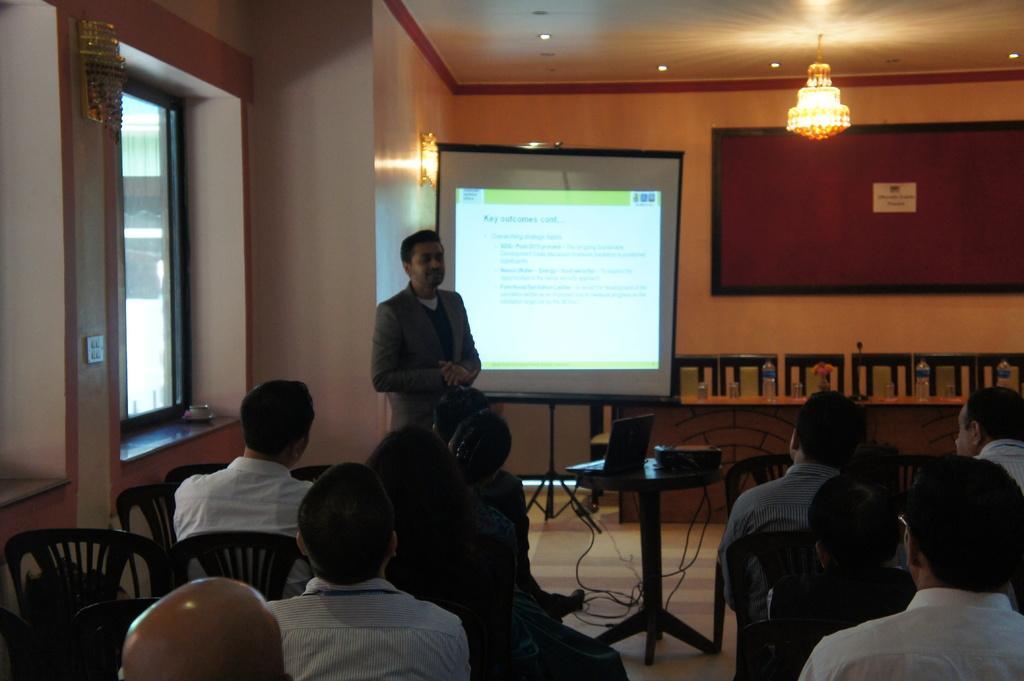Can you describe this image briefly? In this picture we can see a group of people sitting on chairs and a man is standing on the path. Behind the people there is a table and on the table there is a laptop and projector. Behind the man there is a projector screen and a wall. There are ceiling lights and a chandelier on the top. 